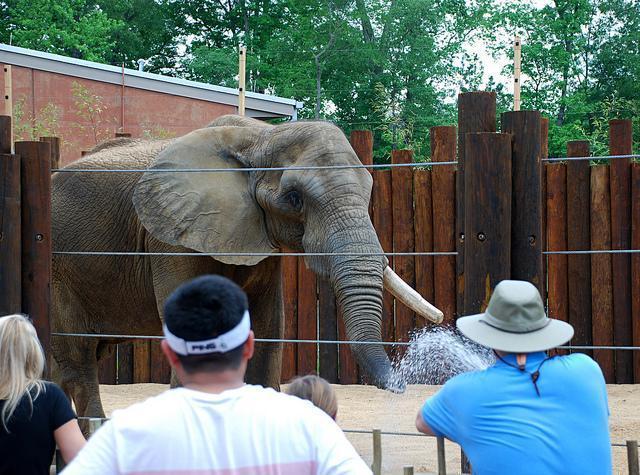How many tusks does the animal have?
Give a very brief answer. 1. How many people are in the picture?
Give a very brief answer. 3. 